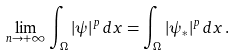<formula> <loc_0><loc_0><loc_500><loc_500>\lim _ { n \to + \infty } \int _ { \Omega } | \psi | ^ { p } \, d x = \int _ { \Omega } | \psi _ { * } | ^ { p } \, d x \, .</formula> 